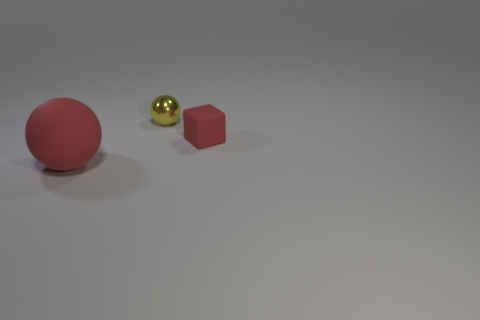Is there anything else that has the same material as the tiny yellow ball? Assuming that the tiny yellow ball in the image is made of a glossy material such as plastic or polished metal, there do not appear to be other objects of similar material in the visual context provided. 